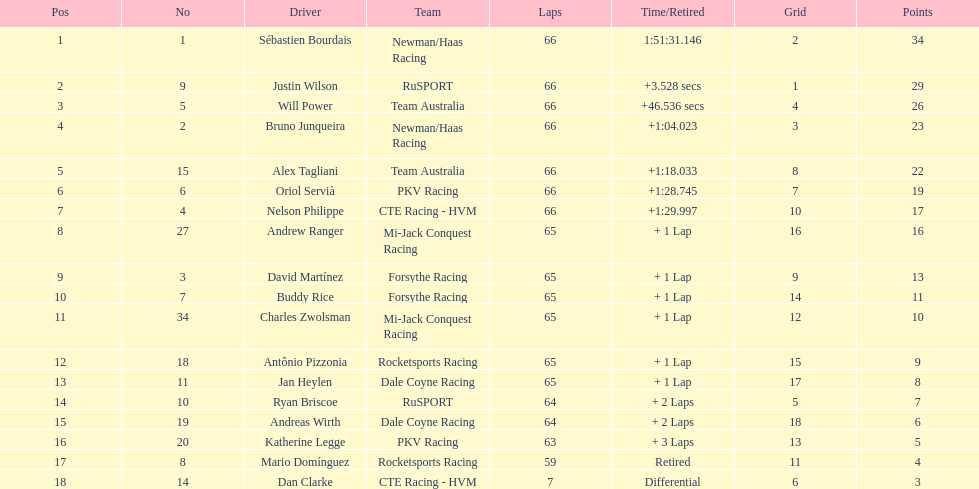What is the total count of laps completed by dan clarke? 7. 